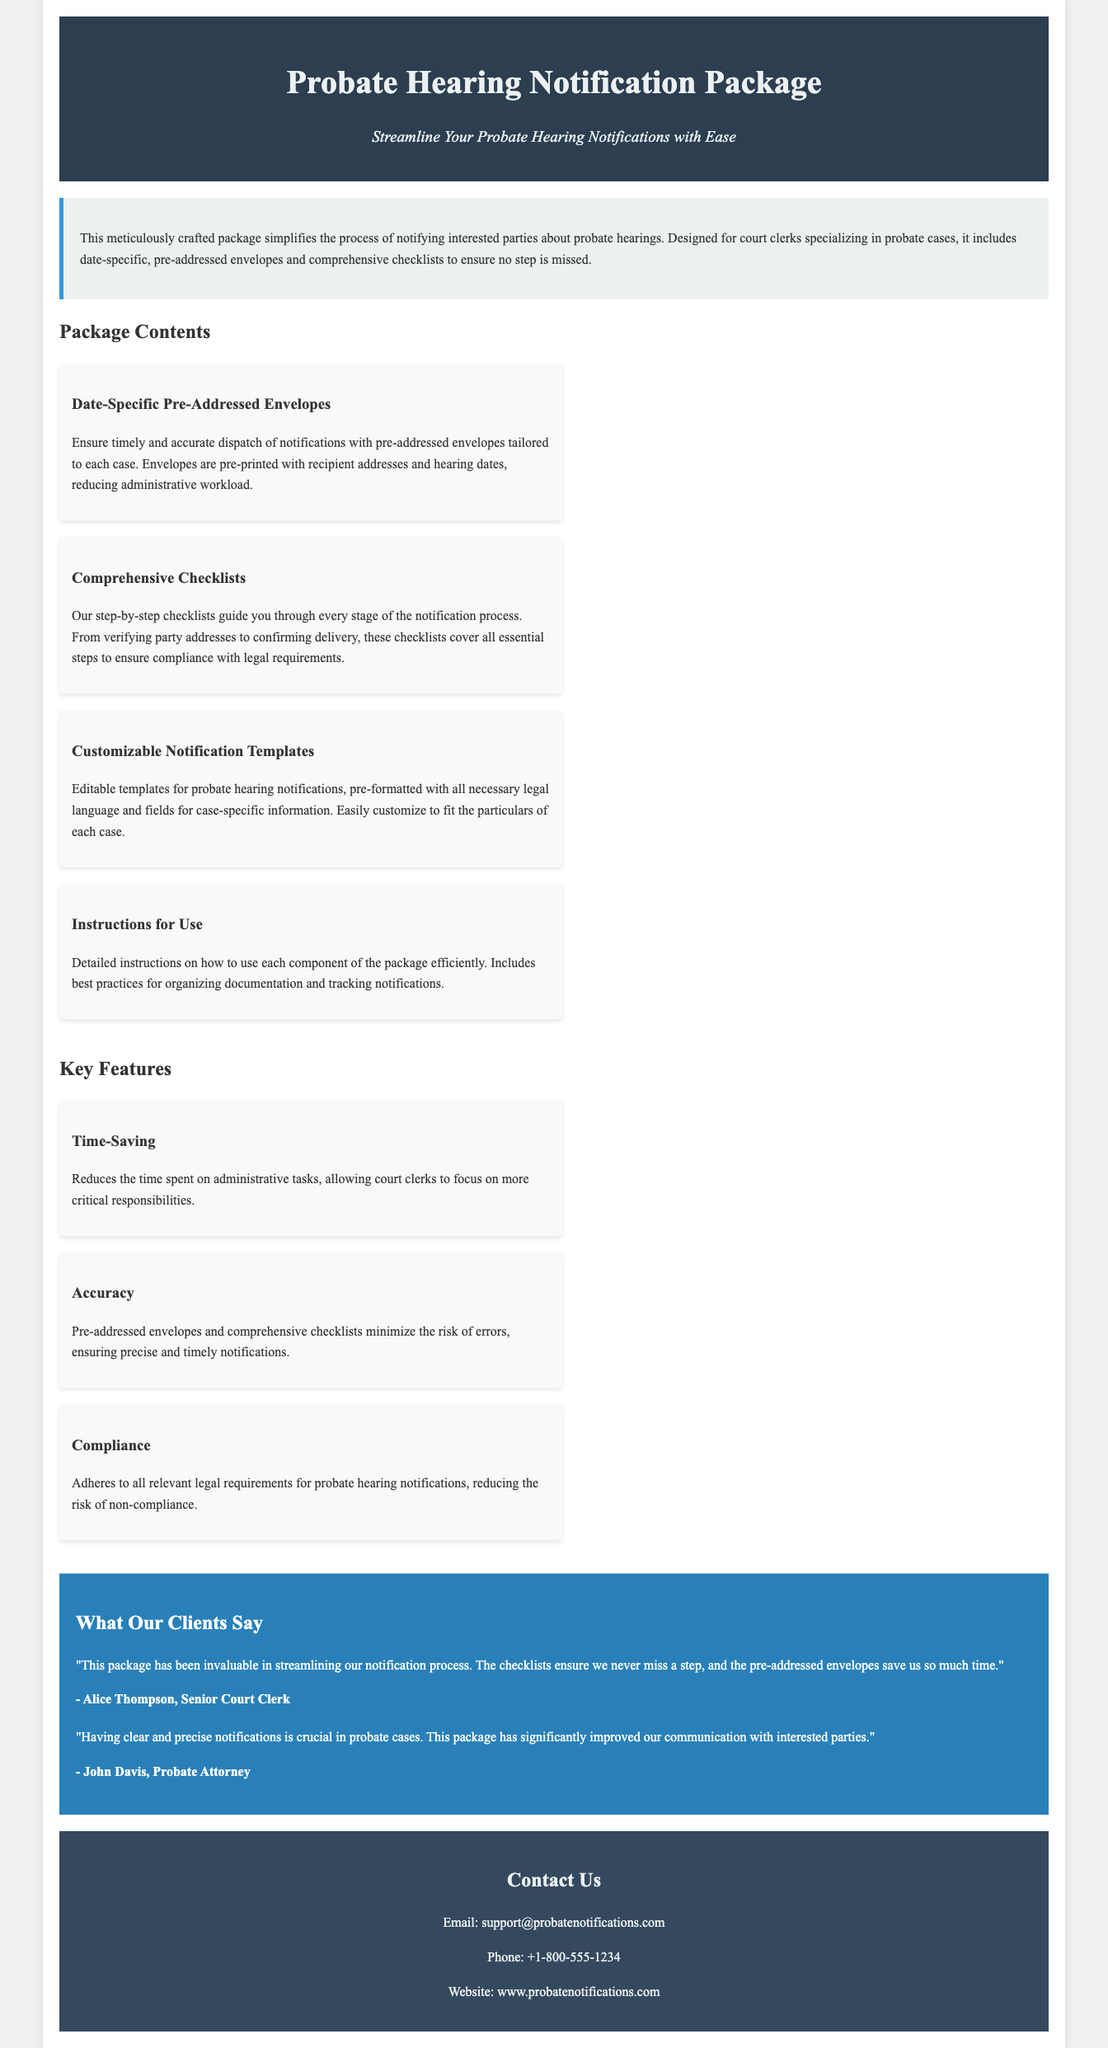What is the title of the document? The title is stated in the header section of the document, which is "Probate Hearing Notification Package."
Answer: Probate Hearing Notification Package Who is the target audience for this package? The document specifies that the package is designed for "court clerks specializing in probate cases."
Answer: court clerks What does the description emphasize about the package? The description highlights that the package simplifies the process of notifying interested parties about probate hearings.
Answer: simplifies the process What are the contents of the package? The document lists four main contents, including date-specific pre-addressed envelopes and checklists for required steps.
Answer: date-specific pre-addressed envelopes What is one of the key features of the package? The document mentions several key features, one of which is "Time-Saving."
Answer: Time-Saving How many testimonials are included in the document? The document features two testimonials from clients who have used the package.
Answer: two What is the email address provided for support? The document specifies the email address for contacting support is support@probatenotifications.com.
Answer: support@probatenotifications.com What do the checklists guide you through? The checklists in the package provide guidance on every stage of the notification process, including verifying party addresses.
Answer: every stage of the notification process What aspect does the package aim to improve in probate cases? One of the central aims noted in the testimonials is to improve communication with interested parties in probate cases.
Answer: improve communication 